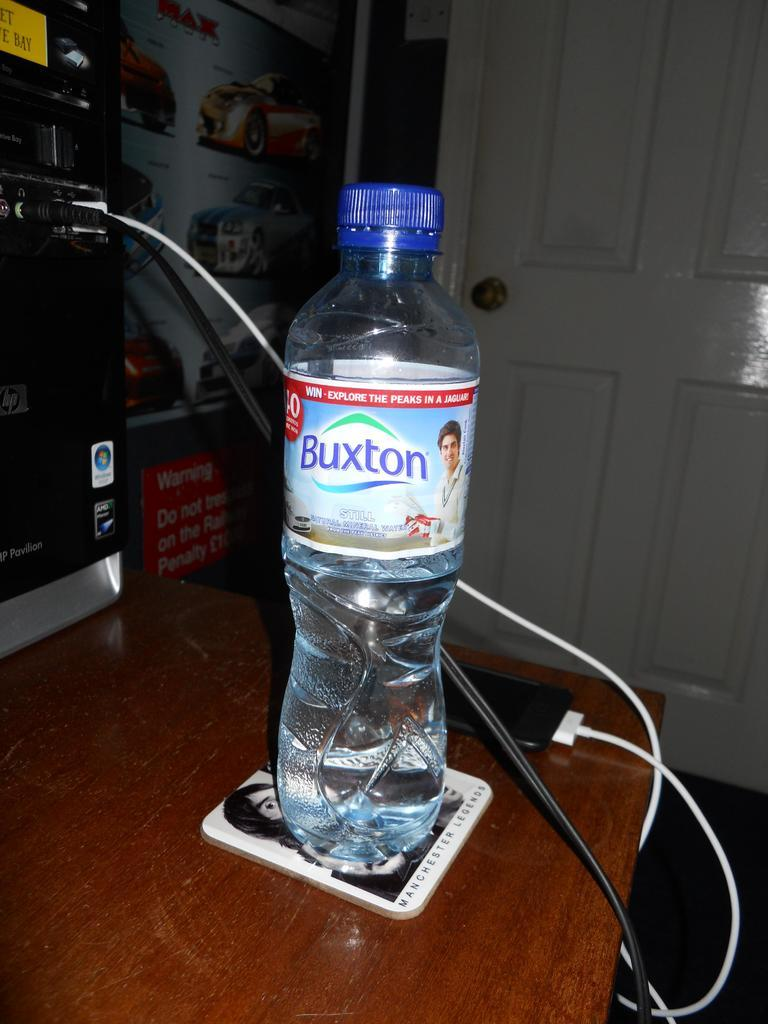<image>
Write a terse but informative summary of the picture. A bottle of water has a blue cap,the bottle is labeled Buxton. 